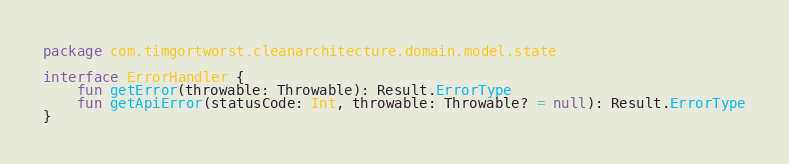Convert code to text. <code><loc_0><loc_0><loc_500><loc_500><_Kotlin_>package com.timgortworst.cleanarchitecture.domain.model.state

interface ErrorHandler {
    fun getError(throwable: Throwable): Result.ErrorType
    fun getApiError(statusCode: Int, throwable: Throwable? = null): Result.ErrorType
}</code> 